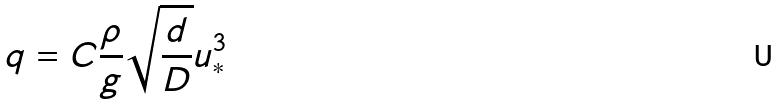Convert formula to latex. <formula><loc_0><loc_0><loc_500><loc_500>q = C \frac { \rho } { g } \sqrt { \frac { d } { D } } u _ { * } ^ { 3 }</formula> 